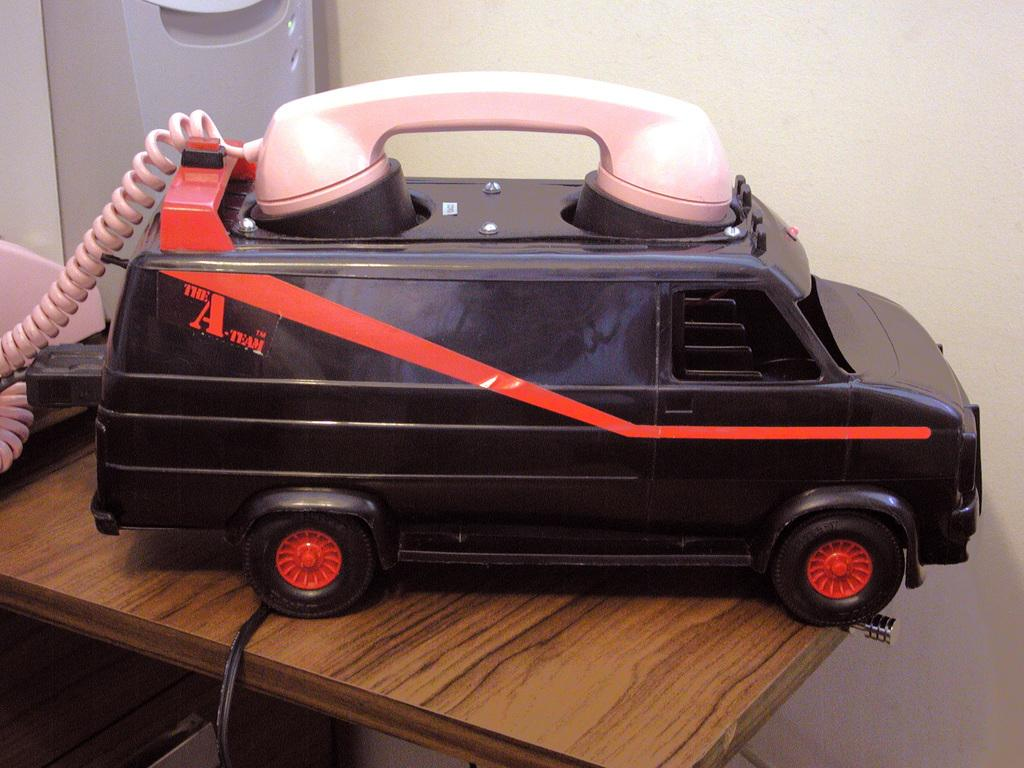What type of toy is in the middle of the image? There is a vehicle toy telephone in the image. Where is the vehicle toy telephone located? The vehicle toy telephone is kept on a table. What can be seen in the background of the image? There is a wall in the background of the image. How does the knot on the vehicle toy telephone affect its functionality in the image? There is no knot present on the vehicle toy telephone in the image. 